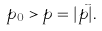<formula> <loc_0><loc_0><loc_500><loc_500>p _ { 0 } > p = | \vec { p } | .</formula> 